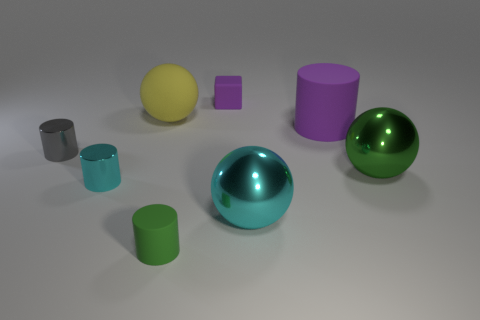Add 1 big cyan spheres. How many objects exist? 9 Subtract all spheres. How many objects are left? 5 Subtract 1 purple cubes. How many objects are left? 7 Subtract all green rubber balls. Subtract all large yellow rubber balls. How many objects are left? 7 Add 6 big green metallic balls. How many big green metallic balls are left? 7 Add 3 big red rubber cubes. How many big red rubber cubes exist? 3 